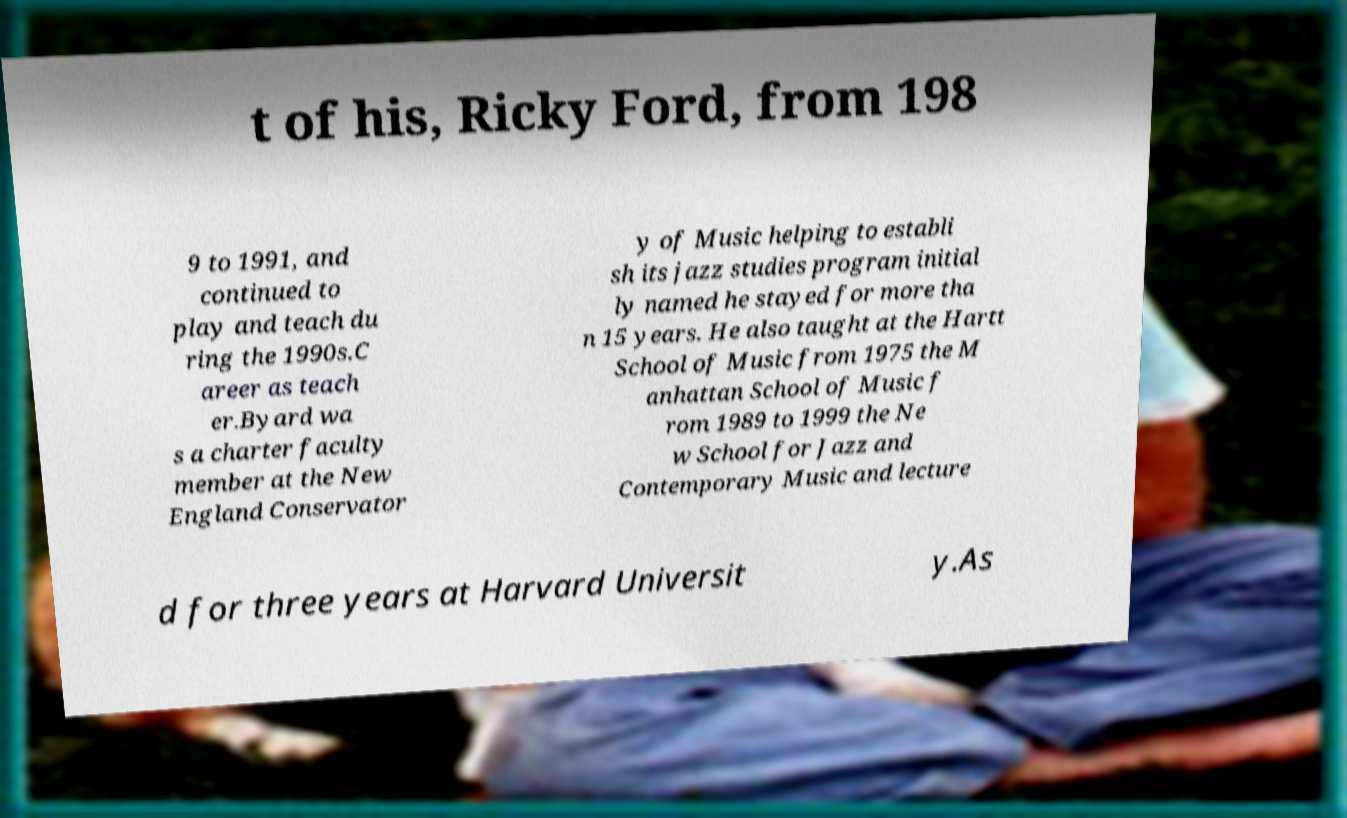I need the written content from this picture converted into text. Can you do that? t of his, Ricky Ford, from 198 9 to 1991, and continued to play and teach du ring the 1990s.C areer as teach er.Byard wa s a charter faculty member at the New England Conservator y of Music helping to establi sh its jazz studies program initial ly named he stayed for more tha n 15 years. He also taught at the Hartt School of Music from 1975 the M anhattan School of Music f rom 1989 to 1999 the Ne w School for Jazz and Contemporary Music and lecture d for three years at Harvard Universit y.As 